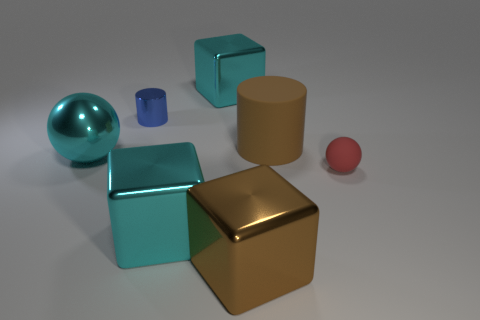There is a object that is both to the right of the brown metal thing and in front of the big ball; what is its material?
Your answer should be compact. Rubber. There is a shiny cylinder that is the same size as the red rubber thing; what color is it?
Your response must be concise. Blue. Is the brown cube made of the same material as the cylinder in front of the tiny blue object?
Your response must be concise. No. How many other objects are there of the same size as the brown cube?
Offer a terse response. 4. There is a shiny block behind the ball on the left side of the brown metallic object; is there a tiny red thing that is in front of it?
Your answer should be very brief. Yes. How big is the blue thing?
Your answer should be compact. Small. What size is the rubber sphere that is in front of the small blue cylinder?
Make the answer very short. Small. Is the size of the cyan metal cube that is in front of the red rubber sphere the same as the tiny shiny cylinder?
Make the answer very short. No. Are there any other things of the same color as the small rubber object?
Your response must be concise. No. What shape is the brown metallic thing?
Make the answer very short. Cube. 